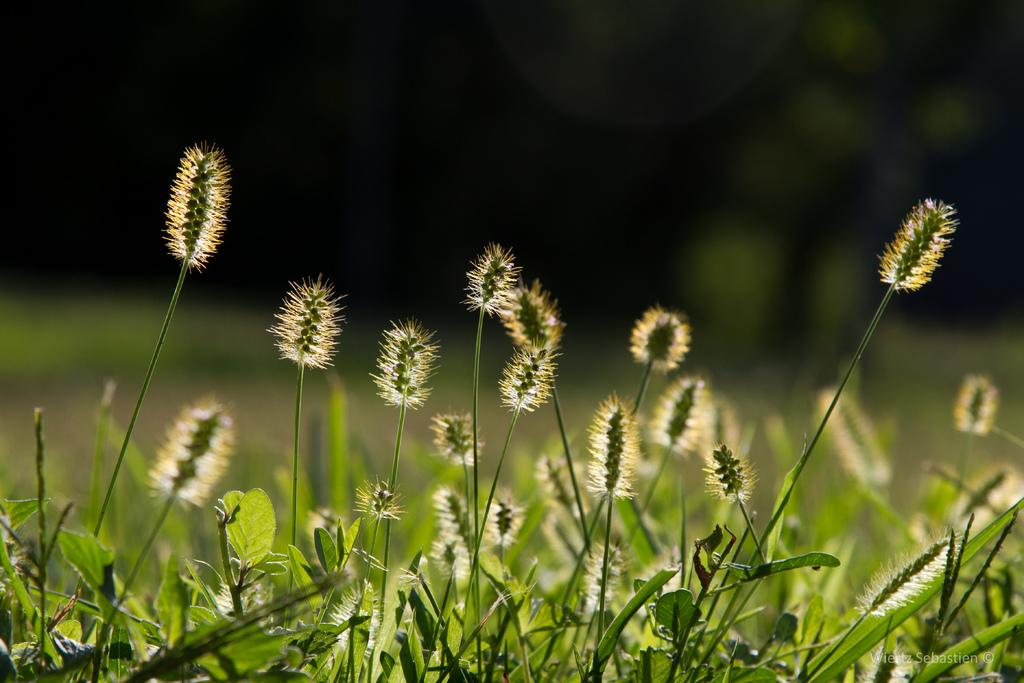What type of living organisms can be seen in the image? Plants can be seen in the image. Can you describe the background of the image? The background of the image is blurred. What color is the soap in the image? There is no soap present in the image. Is there a house visible in the image? There is no house visible in the image. 